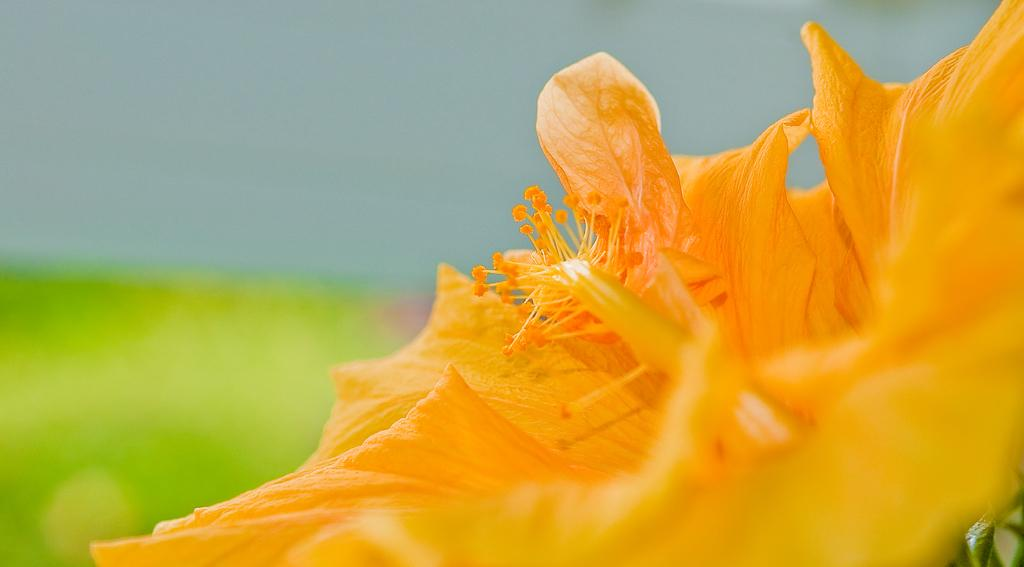What type of flower is in the image? There is an orange flower in the image. Can you describe the background colors in the image? The background of the image has green and blue colors. How many glasses of eggnog are visible in the image? There is no eggnog present in the image. What type of work is the laborer doing in the image? There is no laborer present in the image. How many babies can be seen in the image? There are no babies present in the image. 